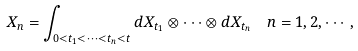Convert formula to latex. <formula><loc_0><loc_0><loc_500><loc_500>X _ { n } & = \int _ { 0 < t _ { 1 } < \cdots < t _ { n } < t } d X _ { t _ { 1 } } \otimes \cdots \otimes d X _ { t _ { n } } \quad n = 1 , 2 , \cdots ,</formula> 